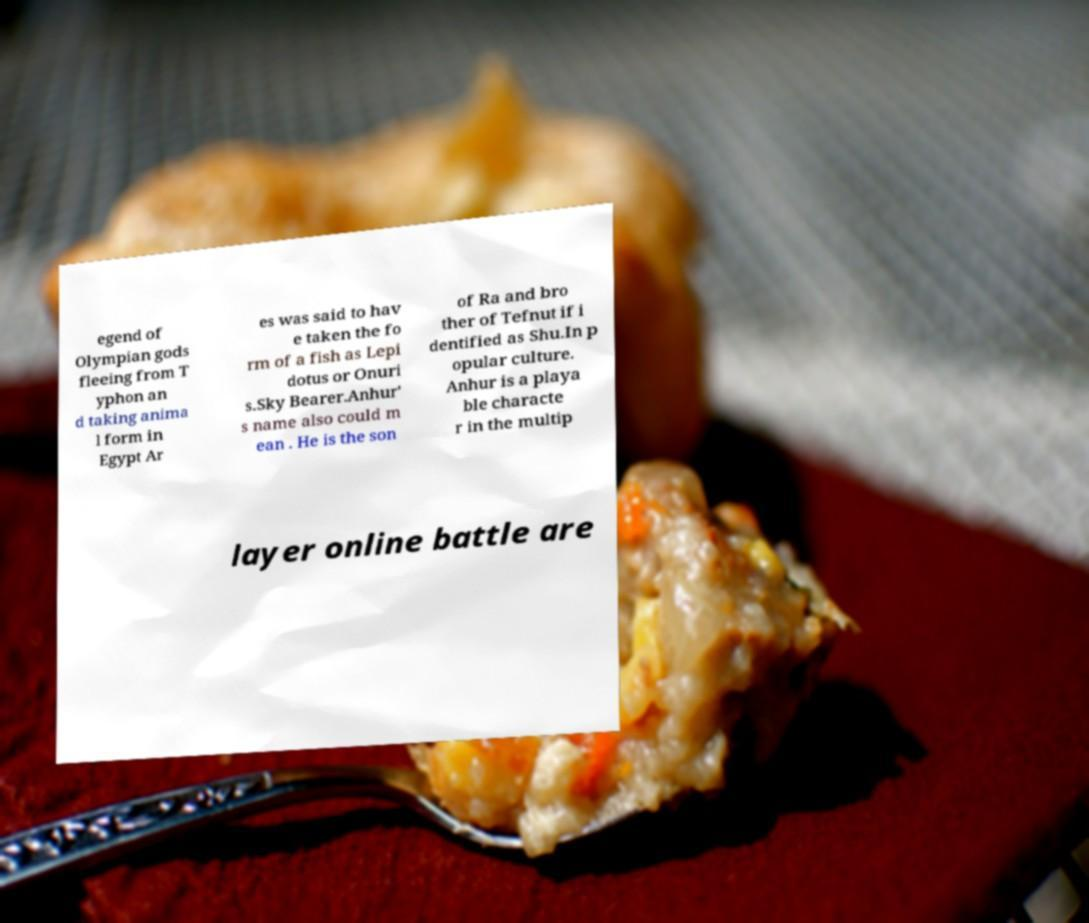Can you accurately transcribe the text from the provided image for me? egend of Olympian gods fleeing from T yphon an d taking anima l form in Egypt Ar es was said to hav e taken the fo rm of a fish as Lepi dotus or Onuri s.Sky Bearer.Anhur' s name also could m ean . He is the son of Ra and bro ther of Tefnut if i dentified as Shu.In p opular culture. Anhur is a playa ble characte r in the multip layer online battle are 